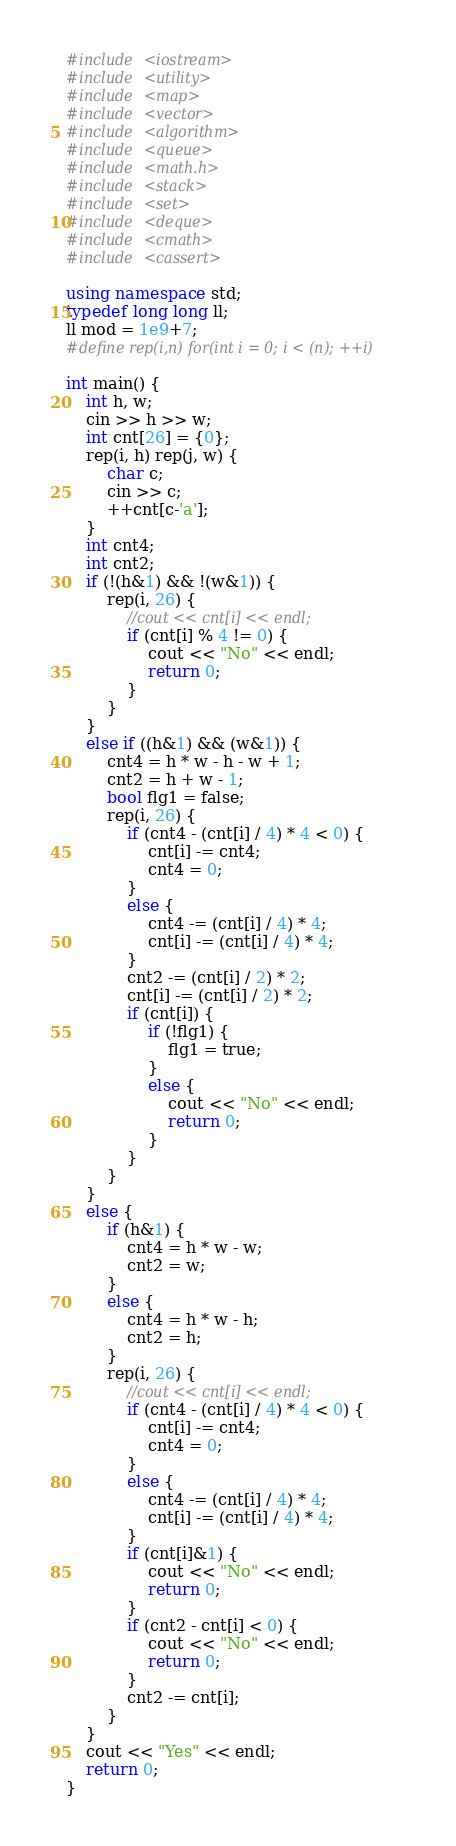Convert code to text. <code><loc_0><loc_0><loc_500><loc_500><_C++_>#include <iostream>
#include <utility>
#include <map>
#include <vector>
#include <algorithm>
#include <queue>
#include <math.h>
#include <stack>
#include <set>
#include <deque>
#include <cmath>
#include <cassert>

using namespace std;
typedef long long ll;
ll mod = 1e9+7;
#define rep(i,n) for(int i = 0; i < (n); ++i)

int main() {
    int h, w;
    cin >> h >> w;
    int cnt[26] = {0};
    rep(i, h) rep(j, w) {
        char c;
        cin >> c;
        ++cnt[c-'a'];
    }
    int cnt4;
    int cnt2;
    if (!(h&1) && !(w&1)) {
        rep(i, 26) {
            //cout << cnt[i] << endl;
            if (cnt[i] % 4 != 0) {
                cout << "No" << endl;
                return 0;
            }
        }
    }
    else if ((h&1) && (w&1)) {
        cnt4 = h * w - h - w + 1;
        cnt2 = h + w - 1;
        bool flg1 = false;
        rep(i, 26) {
            if (cnt4 - (cnt[i] / 4) * 4 < 0) {
                cnt[i] -= cnt4;
                cnt4 = 0;
            }
            else {
                cnt4 -= (cnt[i] / 4) * 4;
                cnt[i] -= (cnt[i] / 4) * 4;
            }
            cnt2 -= (cnt[i] / 2) * 2;
            cnt[i] -= (cnt[i] / 2) * 2;
            if (cnt[i]) {
                if (!flg1) {
                    flg1 = true;
                }
                else {
                    cout << "No" << endl;
                    return 0;
                }
            }
        }
    }
    else {
        if (h&1) {
            cnt4 = h * w - w;
            cnt2 = w;
        }
        else {
            cnt4 = h * w - h;
            cnt2 = h;
        }
        rep(i, 26) {
            //cout << cnt[i] << endl;
            if (cnt4 - (cnt[i] / 4) * 4 < 0) {
                cnt[i] -= cnt4;
                cnt4 = 0;
            }
            else {
                cnt4 -= (cnt[i] / 4) * 4;
                cnt[i] -= (cnt[i] / 4) * 4;
            }
            if (cnt[i]&1) {
                cout << "No" << endl;
                return 0;
            }
            if (cnt2 - cnt[i] < 0) {
                cout << "No" << endl;
                return 0;
            }
            cnt2 -= cnt[i];
        }
    }
    cout << "Yes" << endl;
    return 0;
}
</code> 